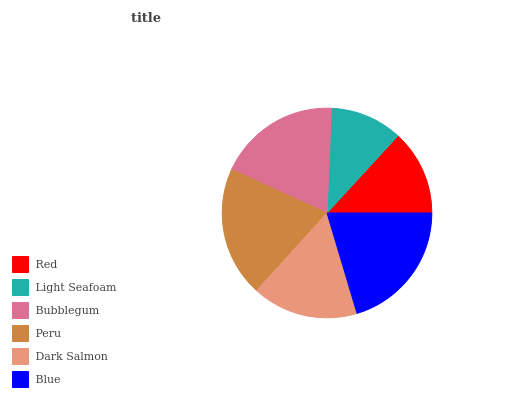Is Light Seafoam the minimum?
Answer yes or no. Yes. Is Blue the maximum?
Answer yes or no. Yes. Is Bubblegum the minimum?
Answer yes or no. No. Is Bubblegum the maximum?
Answer yes or no. No. Is Bubblegum greater than Light Seafoam?
Answer yes or no. Yes. Is Light Seafoam less than Bubblegum?
Answer yes or no. Yes. Is Light Seafoam greater than Bubblegum?
Answer yes or no. No. Is Bubblegum less than Light Seafoam?
Answer yes or no. No. Is Bubblegum the high median?
Answer yes or no. Yes. Is Dark Salmon the low median?
Answer yes or no. Yes. Is Red the high median?
Answer yes or no. No. Is Bubblegum the low median?
Answer yes or no. No. 